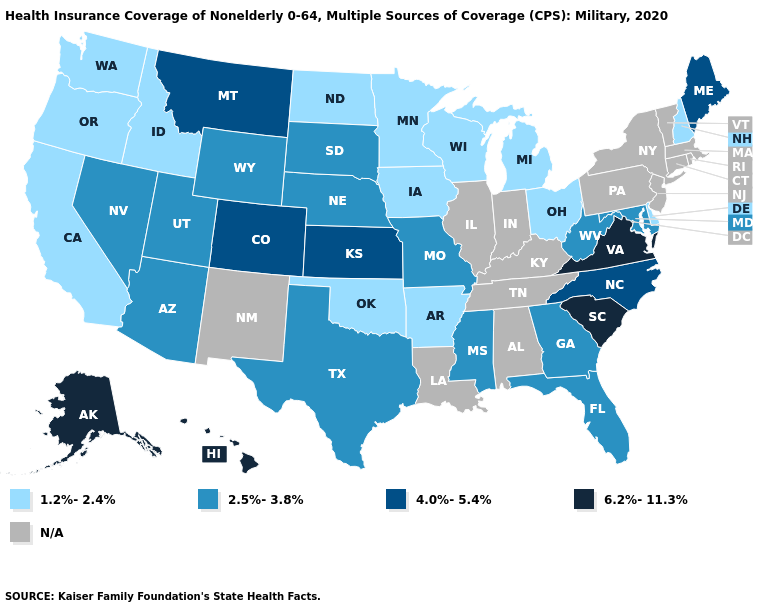How many symbols are there in the legend?
Write a very short answer. 5. Which states hav the highest value in the South?
Give a very brief answer. South Carolina, Virginia. Name the states that have a value in the range 4.0%-5.4%?
Be succinct. Colorado, Kansas, Maine, Montana, North Carolina. What is the highest value in the USA?
Keep it brief. 6.2%-11.3%. What is the lowest value in states that border Utah?
Write a very short answer. 1.2%-2.4%. Name the states that have a value in the range 4.0%-5.4%?
Concise answer only. Colorado, Kansas, Maine, Montana, North Carolina. Name the states that have a value in the range 2.5%-3.8%?
Short answer required. Arizona, Florida, Georgia, Maryland, Mississippi, Missouri, Nebraska, Nevada, South Dakota, Texas, Utah, West Virginia, Wyoming. Name the states that have a value in the range 1.2%-2.4%?
Give a very brief answer. Arkansas, California, Delaware, Idaho, Iowa, Michigan, Minnesota, New Hampshire, North Dakota, Ohio, Oklahoma, Oregon, Washington, Wisconsin. Does West Virginia have the lowest value in the USA?
Answer briefly. No. What is the highest value in the USA?
Answer briefly. 6.2%-11.3%. Name the states that have a value in the range 1.2%-2.4%?
Answer briefly. Arkansas, California, Delaware, Idaho, Iowa, Michigan, Minnesota, New Hampshire, North Dakota, Ohio, Oklahoma, Oregon, Washington, Wisconsin. What is the value of Oregon?
Short answer required. 1.2%-2.4%. What is the value of California?
Short answer required. 1.2%-2.4%. Which states have the lowest value in the USA?
Short answer required. Arkansas, California, Delaware, Idaho, Iowa, Michigan, Minnesota, New Hampshire, North Dakota, Ohio, Oklahoma, Oregon, Washington, Wisconsin. 